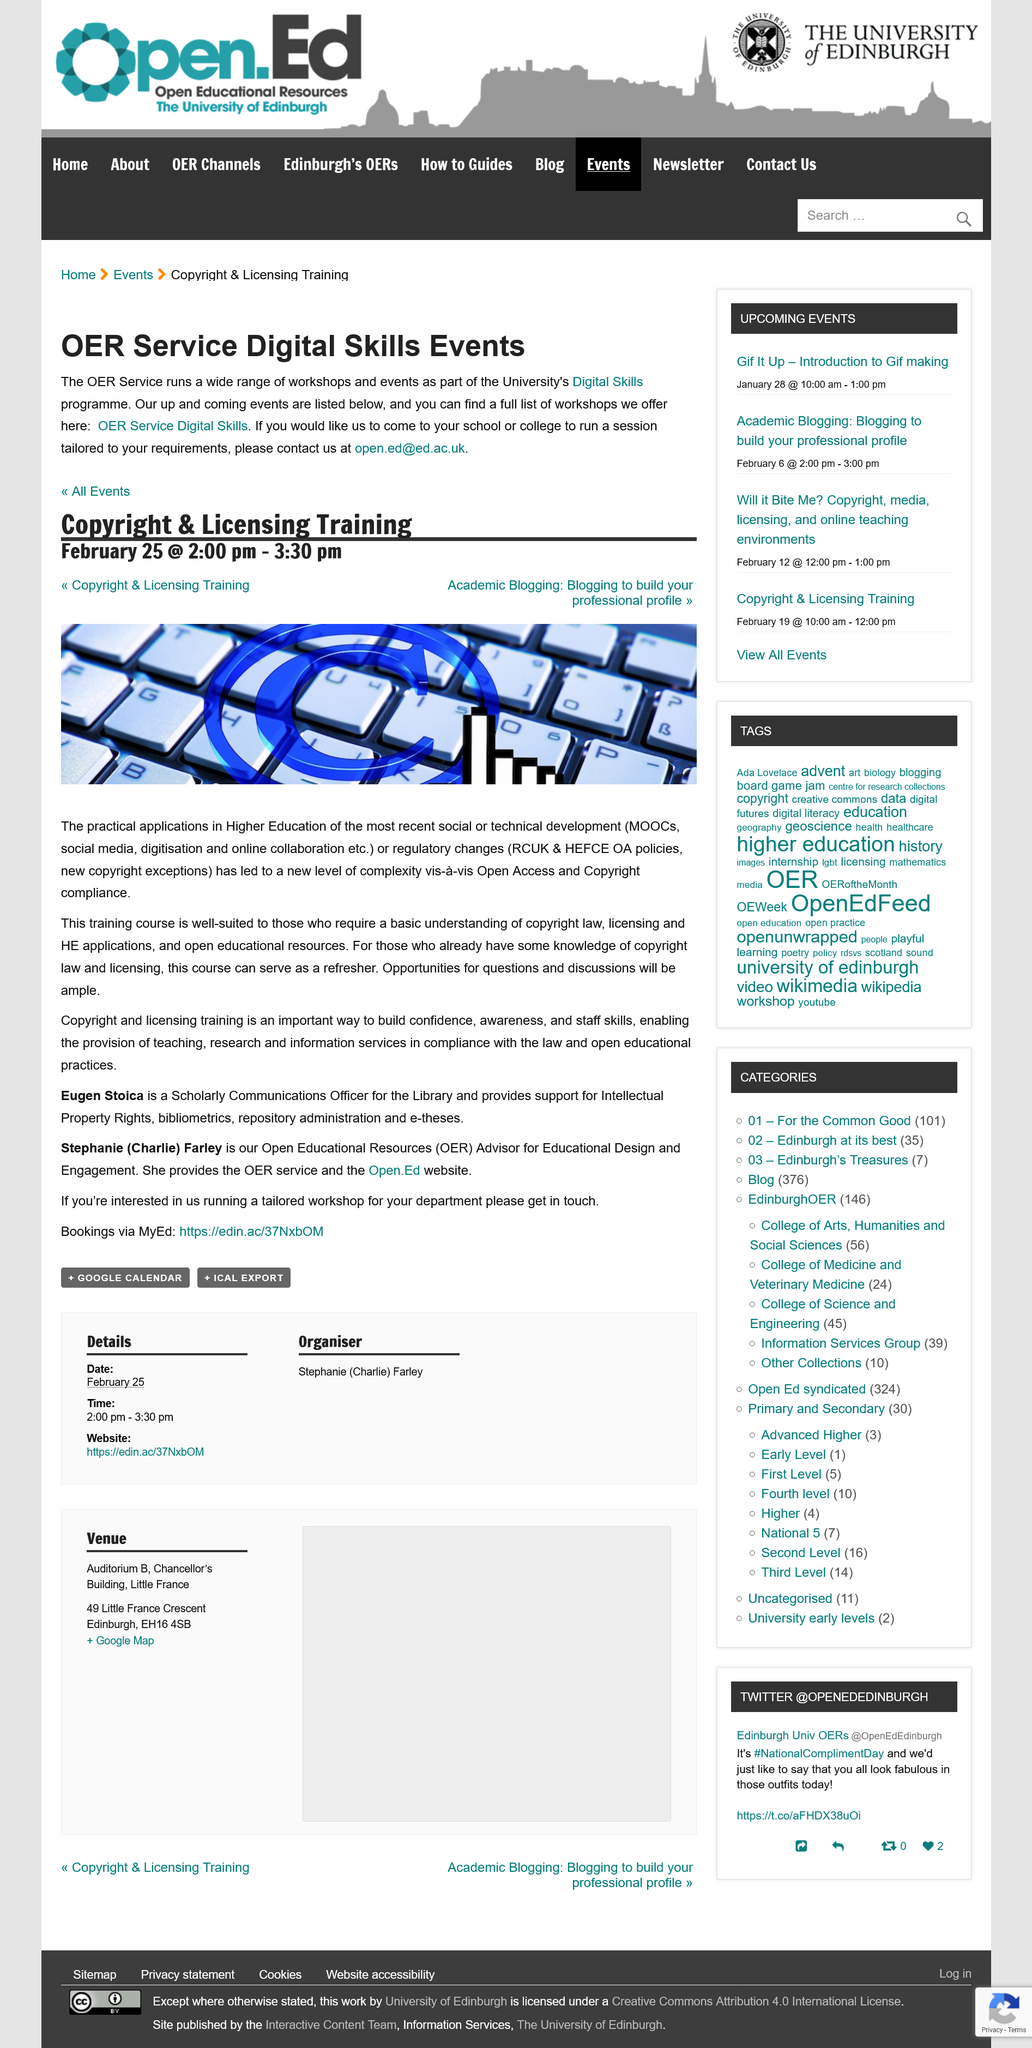Point out several critical features in this image. We are currently offering a training course on copyright. The post covers content related to copyright and licensing training. The training course is suitable for individuals who require a basic understanding of copyright law. 